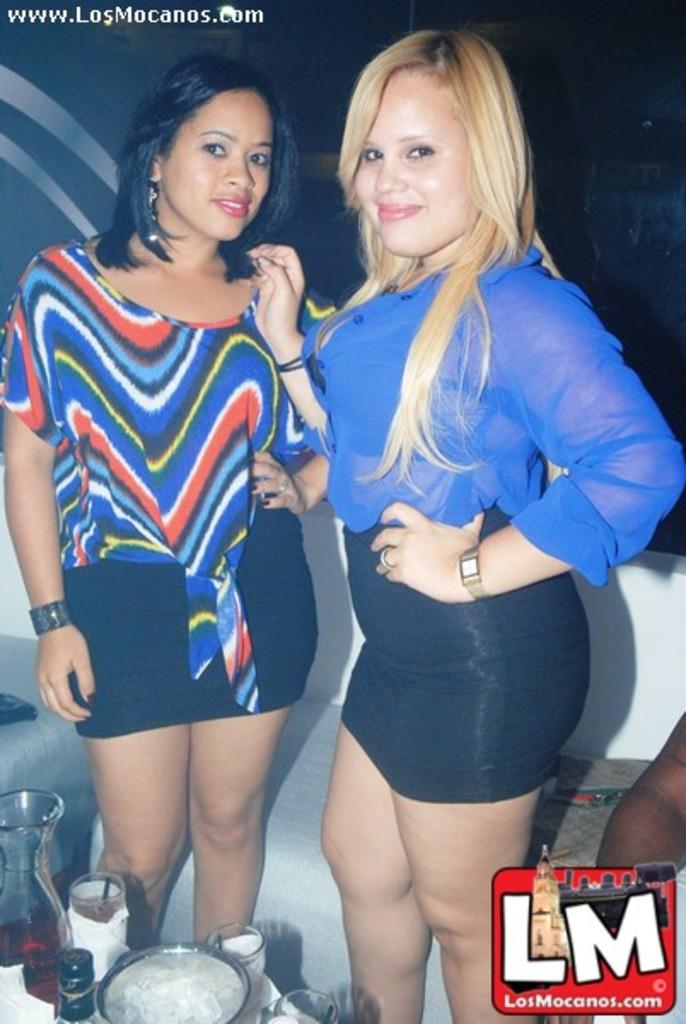<image>
Summarize the visual content of the image. Two women pose on boat with the caption LosMocanos.com 